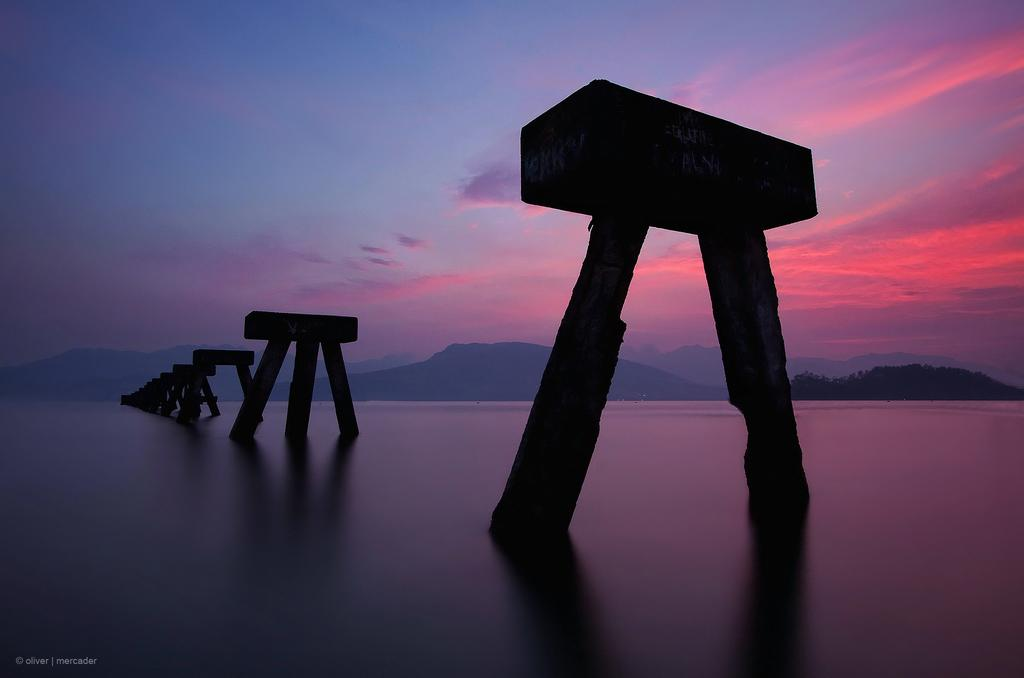What natural feature is located at the bottom of the image? There is a river at the bottom of the image. What structures are present in the river? There are walls in the river. What can be seen in the distance in the image? There are mountains and trees in the background of the image. What is visible at the top of the image? The sky is visible at the top of the image. What type of bait is being used to catch fish in the river? There is no indication of fishing or bait in the image; it only shows a river with walls and a background of mountains and trees. What kind of food is being prepared on the riverbank? There is no food preparation or cooking activity visible in the image. 